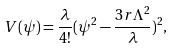Convert formula to latex. <formula><loc_0><loc_0><loc_500><loc_500>V ( \psi ) = \frac { \lambda } { 4 ! } ( \psi ^ { 2 } - \frac { 3 r \Lambda ^ { 2 } } { \lambda } ) ^ { 2 } ,</formula> 